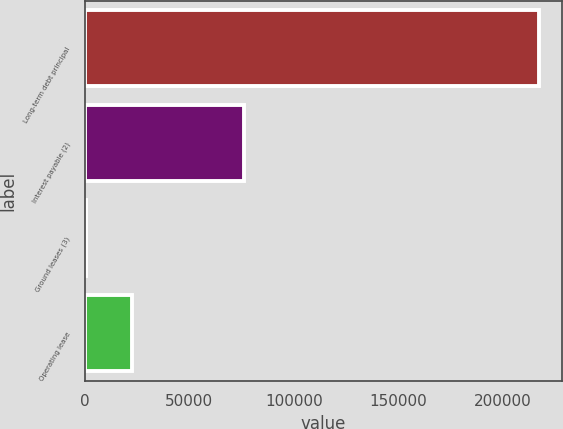Convert chart to OTSL. <chart><loc_0><loc_0><loc_500><loc_500><bar_chart><fcel>Long-term debt principal<fcel>Interest payable (2)<fcel>Ground leases (3)<fcel>Operating lease<nl><fcel>217011<fcel>76373<fcel>806<fcel>22426.5<nl></chart> 